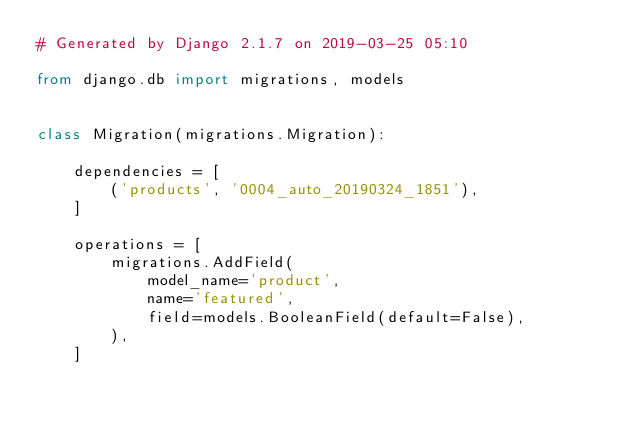<code> <loc_0><loc_0><loc_500><loc_500><_Python_># Generated by Django 2.1.7 on 2019-03-25 05:10

from django.db import migrations, models


class Migration(migrations.Migration):

    dependencies = [
        ('products', '0004_auto_20190324_1851'),
    ]

    operations = [
        migrations.AddField(
            model_name='product',
            name='featured',
            field=models.BooleanField(default=False),
        ),
    ]
</code> 